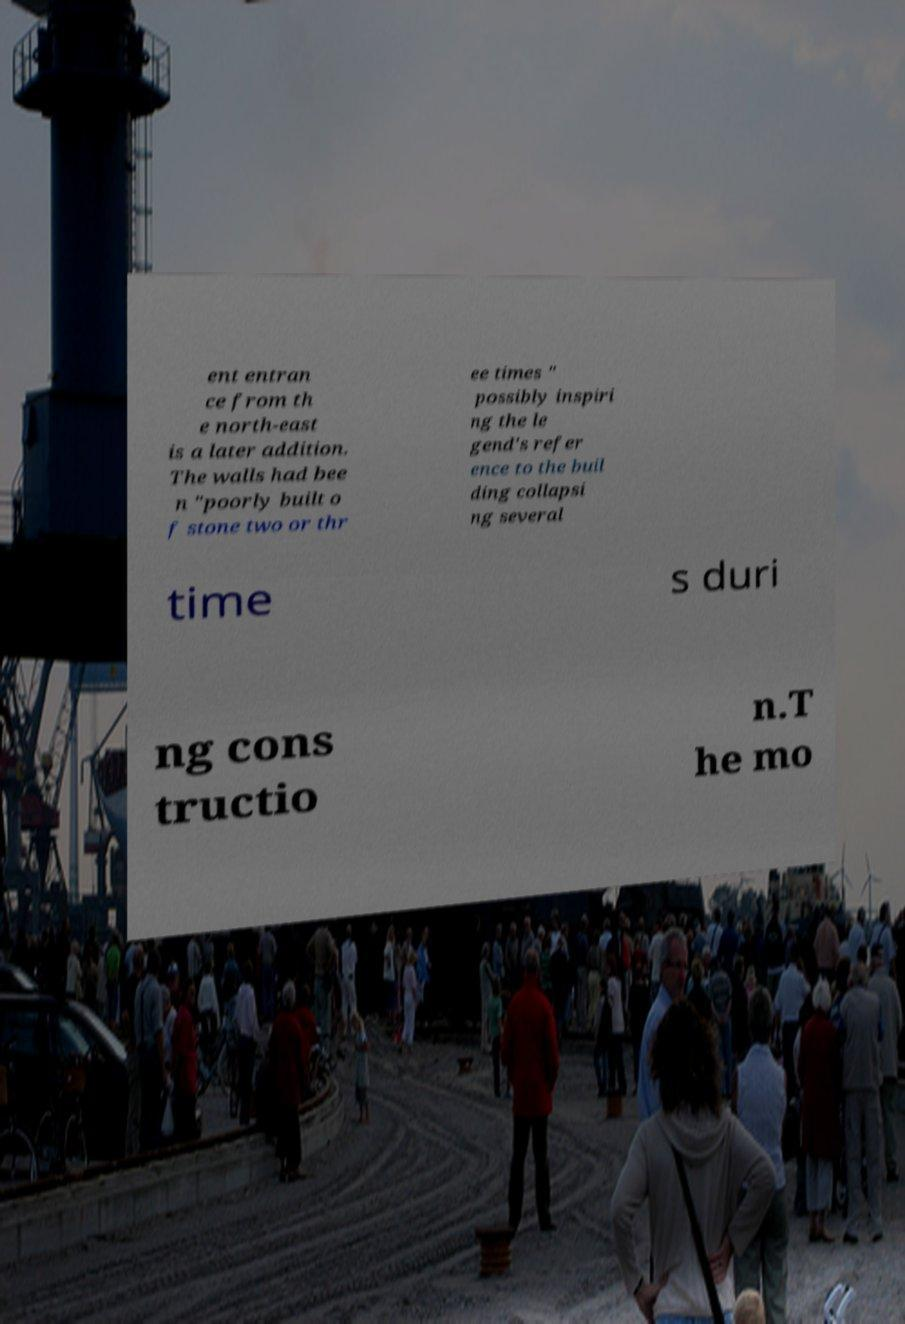Please identify and transcribe the text found in this image. ent entran ce from th e north-east is a later addition. The walls had bee n "poorly built o f stone two or thr ee times " possibly inspiri ng the le gend's refer ence to the buil ding collapsi ng several time s duri ng cons tructio n.T he mo 